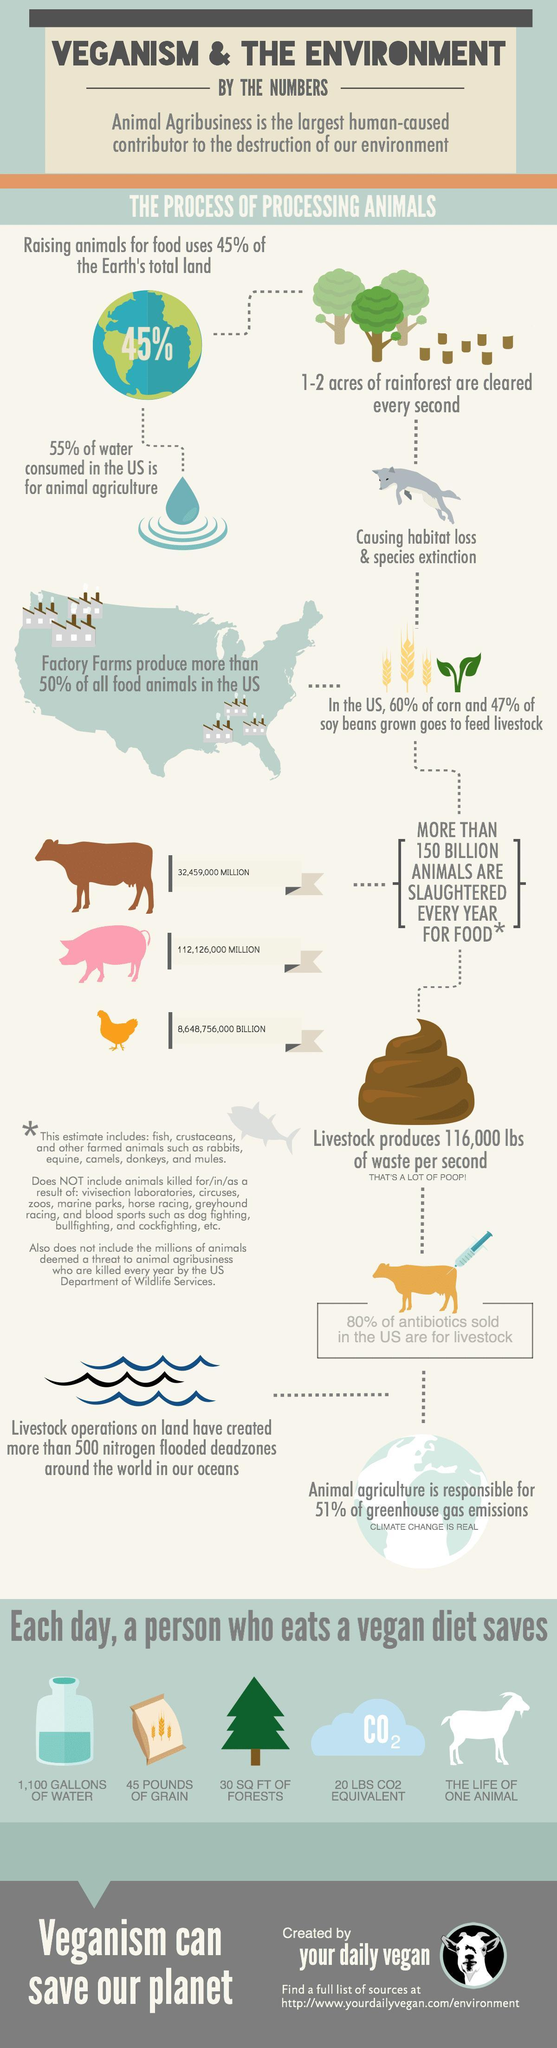How many Chickens are being killed for food annually in billion?
Answer the question with a short phrase. 8,648,756,000 billion What amount of Carbon dioxide is saved by a vegan per day? 20 LBS What quantity of Grains is saved by a vegan per day? 45 pounds of grain How many Pigs are being killed for food annually in million? 112,126,000 million How many Cattles are being killed for food annually in million? 32,459,000 How much Forest is saved by a vegan per day? 30 SQ FT of forests 